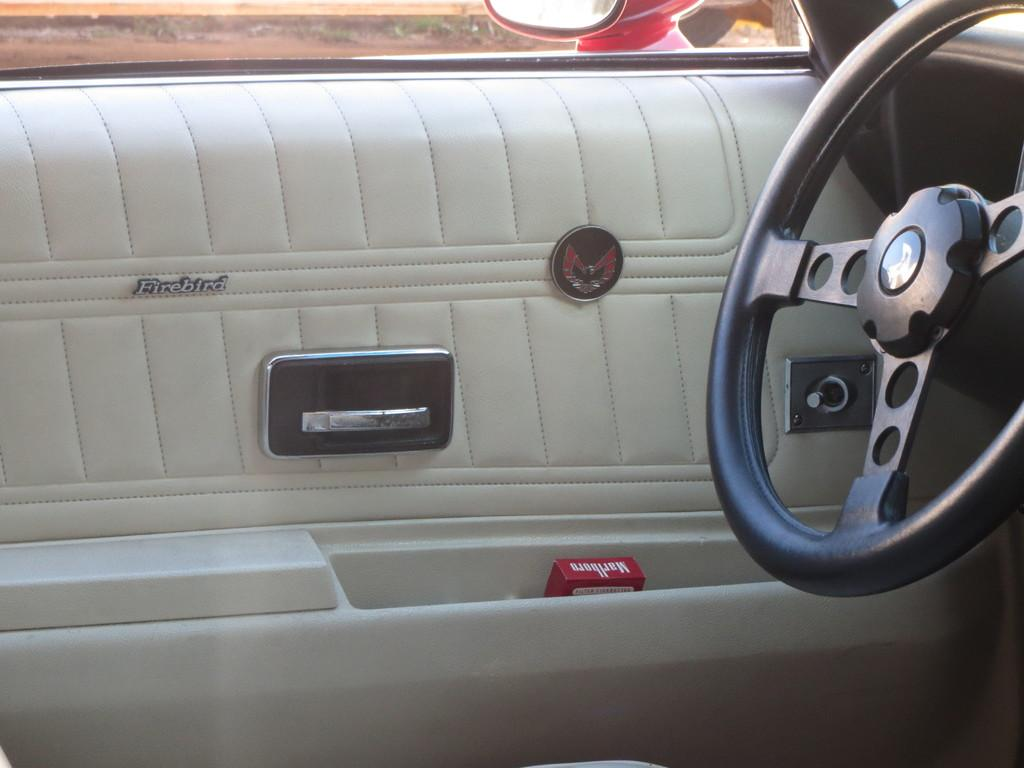What is the setting of the image? The image shows the inside of a car. What can be found inside the car? There is an object and a logo in the car. Is there any text present in the car? Yes, there is text in the car. Where is the steering wheel located in the car? The steering wheel is on the right side of the car. What can be seen through the mirror in the car? The ground is visible at the top of the image through a mirror. Can you tell me how many chess pieces are on the building in the image? There is no building or chess pieces present in the image; it shows the inside of a car. What type of ground is visible through the mirror in the image? The type of ground cannot be determined from the image, as only the ground itself is visible through the mirror. 